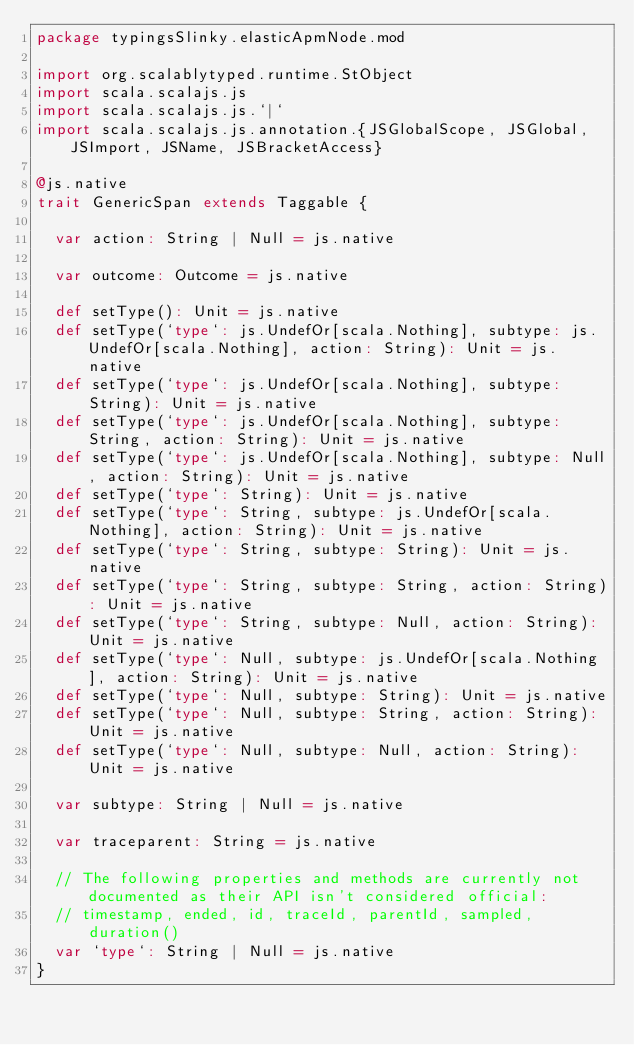<code> <loc_0><loc_0><loc_500><loc_500><_Scala_>package typingsSlinky.elasticApmNode.mod

import org.scalablytyped.runtime.StObject
import scala.scalajs.js
import scala.scalajs.js.`|`
import scala.scalajs.js.annotation.{JSGlobalScope, JSGlobal, JSImport, JSName, JSBracketAccess}

@js.native
trait GenericSpan extends Taggable {
  
  var action: String | Null = js.native
  
  var outcome: Outcome = js.native
  
  def setType(): Unit = js.native
  def setType(`type`: js.UndefOr[scala.Nothing], subtype: js.UndefOr[scala.Nothing], action: String): Unit = js.native
  def setType(`type`: js.UndefOr[scala.Nothing], subtype: String): Unit = js.native
  def setType(`type`: js.UndefOr[scala.Nothing], subtype: String, action: String): Unit = js.native
  def setType(`type`: js.UndefOr[scala.Nothing], subtype: Null, action: String): Unit = js.native
  def setType(`type`: String): Unit = js.native
  def setType(`type`: String, subtype: js.UndefOr[scala.Nothing], action: String): Unit = js.native
  def setType(`type`: String, subtype: String): Unit = js.native
  def setType(`type`: String, subtype: String, action: String): Unit = js.native
  def setType(`type`: String, subtype: Null, action: String): Unit = js.native
  def setType(`type`: Null, subtype: js.UndefOr[scala.Nothing], action: String): Unit = js.native
  def setType(`type`: Null, subtype: String): Unit = js.native
  def setType(`type`: Null, subtype: String, action: String): Unit = js.native
  def setType(`type`: Null, subtype: Null, action: String): Unit = js.native
  
  var subtype: String | Null = js.native
  
  var traceparent: String = js.native
  
  // The following properties and methods are currently not documented as their API isn't considered official:
  // timestamp, ended, id, traceId, parentId, sampled, duration()
  var `type`: String | Null = js.native
}
</code> 